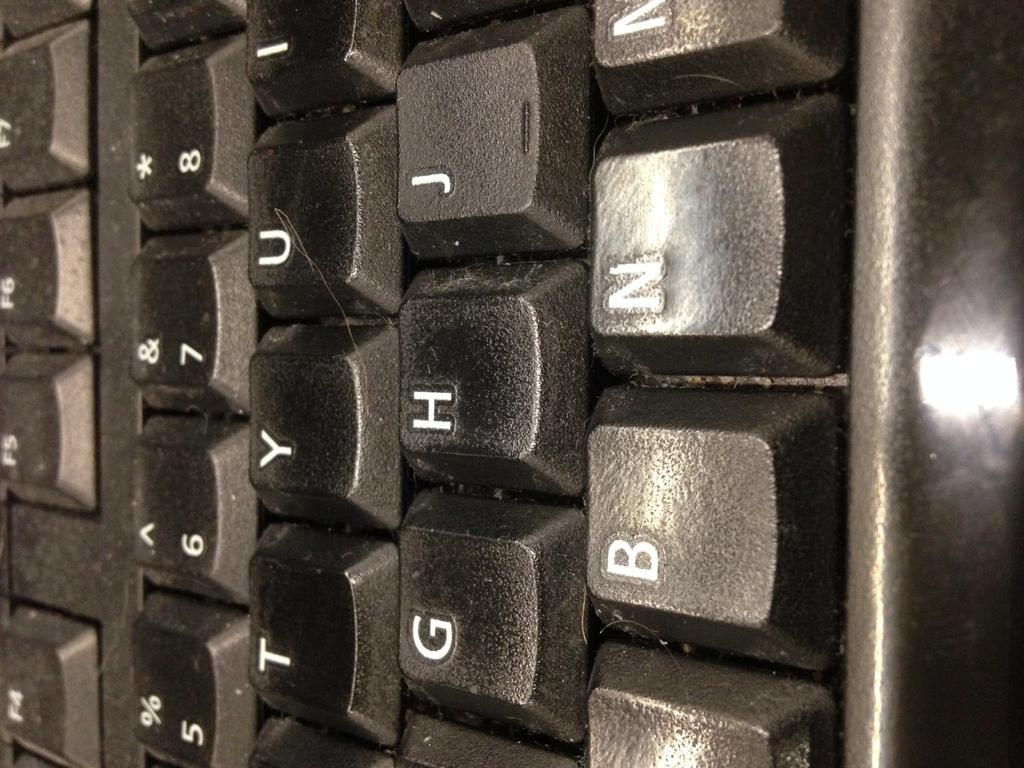<image>
Give a short and clear explanation of the subsequent image. A close up of a keyboard with the letters B and N on the bottom. 